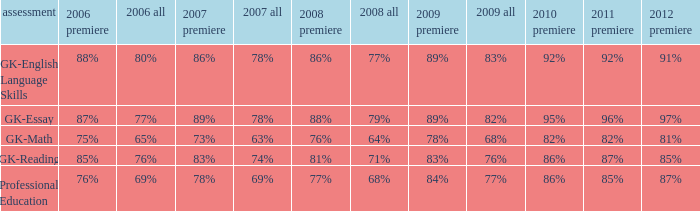What is the percentage for first time 2011 when the first time in 2009 is 68%? 82%. 